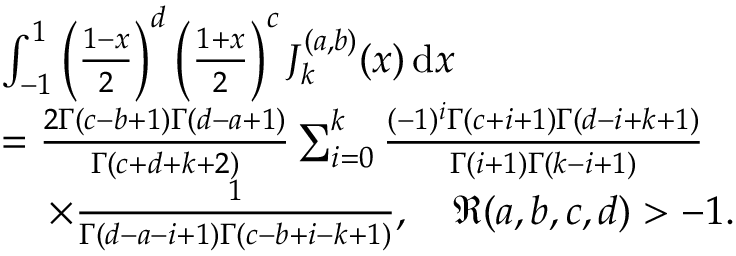<formula> <loc_0><loc_0><loc_500><loc_500>\begin{array} { r l } & { \int _ { - 1 } ^ { 1 } \left ( \frac { 1 - x } { 2 } \right ) ^ { d } \left ( \frac { 1 + x } { 2 } \right ) ^ { c } J _ { k } ^ { ( a , b ) } ( x ) \, d x } \\ & { = \frac { 2 \Gamma ( c - b + 1 ) \Gamma ( d - a + 1 ) } { \Gamma ( c + d + k + 2 ) } \sum _ { i = 0 } ^ { k } \frac { ( - 1 ) ^ { i } \Gamma ( c + i + 1 ) \Gamma ( d - i + k + 1 ) } { \Gamma ( i + 1 ) \Gamma ( k - i + 1 ) } } \\ & { \, \times \frac { 1 } { \Gamma ( d - a - i + 1 ) \Gamma ( c - b + i - k + 1 ) } , \quad \Re ( a , b , c , d ) > - 1 . } \end{array}</formula> 